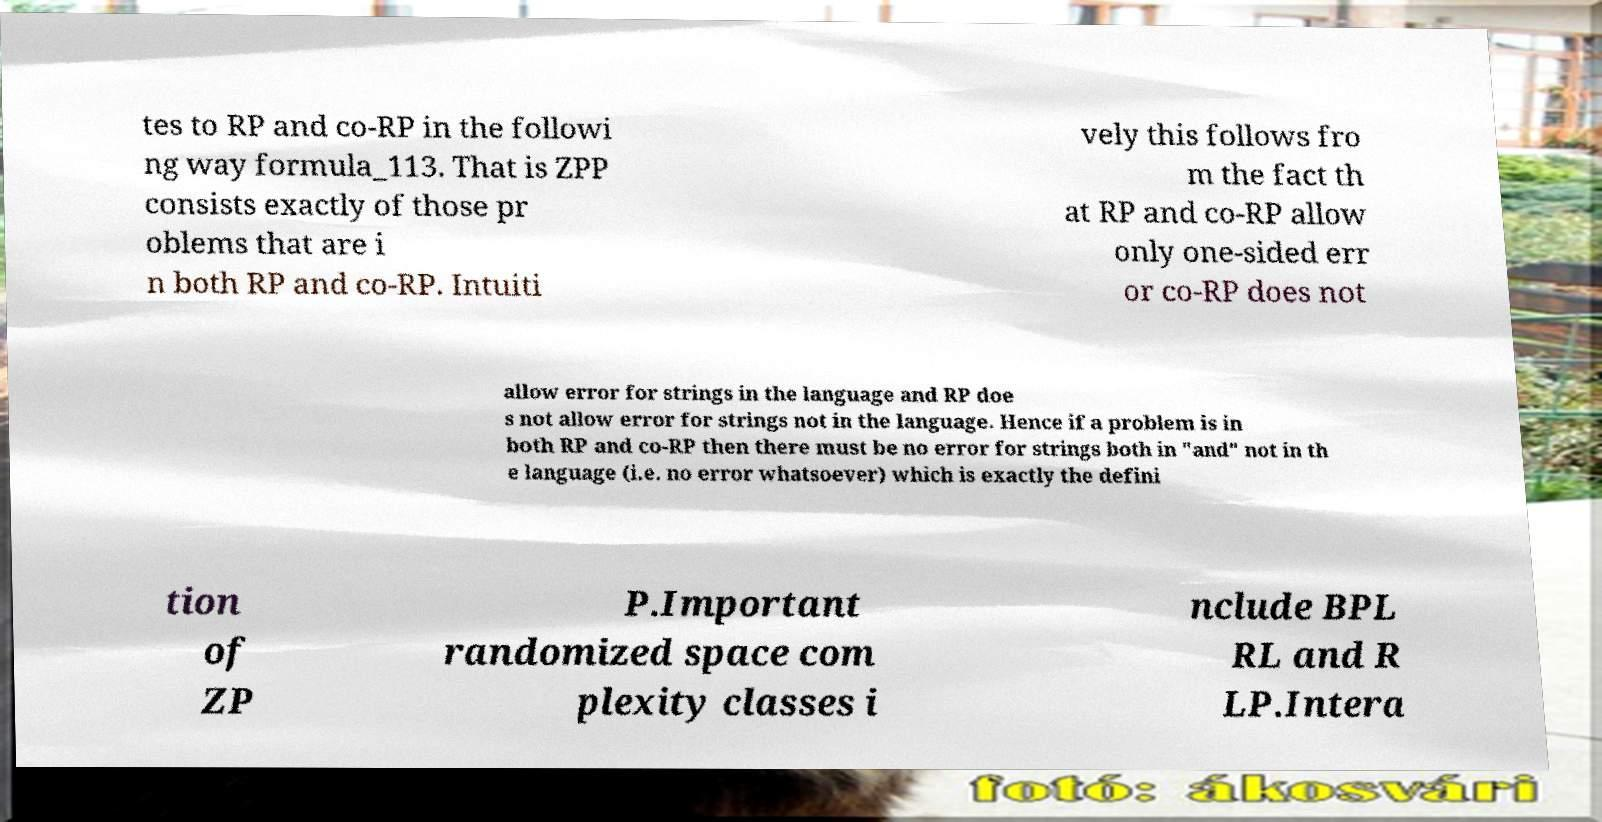Can you read and provide the text displayed in the image?This photo seems to have some interesting text. Can you extract and type it out for me? tes to RP and co-RP in the followi ng way formula_113. That is ZPP consists exactly of those pr oblems that are i n both RP and co-RP. Intuiti vely this follows fro m the fact th at RP and co-RP allow only one-sided err or co-RP does not allow error for strings in the language and RP doe s not allow error for strings not in the language. Hence if a problem is in both RP and co-RP then there must be no error for strings both in "and" not in th e language (i.e. no error whatsoever) which is exactly the defini tion of ZP P.Important randomized space com plexity classes i nclude BPL RL and R LP.Intera 